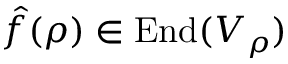<formula> <loc_0><loc_0><loc_500><loc_500>{ \hat { f } } ( \rho ) \in { E n d } ( V _ { \rho } )</formula> 